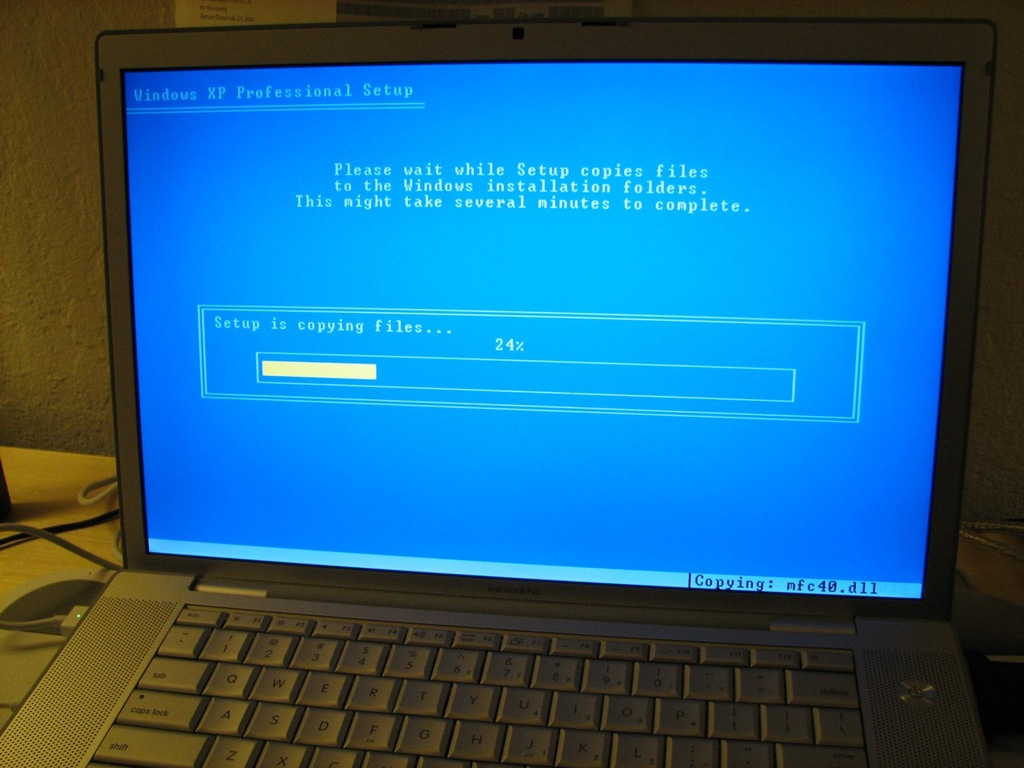What might be some typical issues users encounter during this installation phase? During the installation of Windows XP, users often encountered issues such as system compatibility problems, missing device drivers, or software conflicts that could cause the system to freeze or crash. Slow installation speeds and errors due to scratched or damaged installation media were also common. Users needed to ensure that their hardware met the system requirements and sometimes had to enter BIOS settings to adjust boot priorities. 